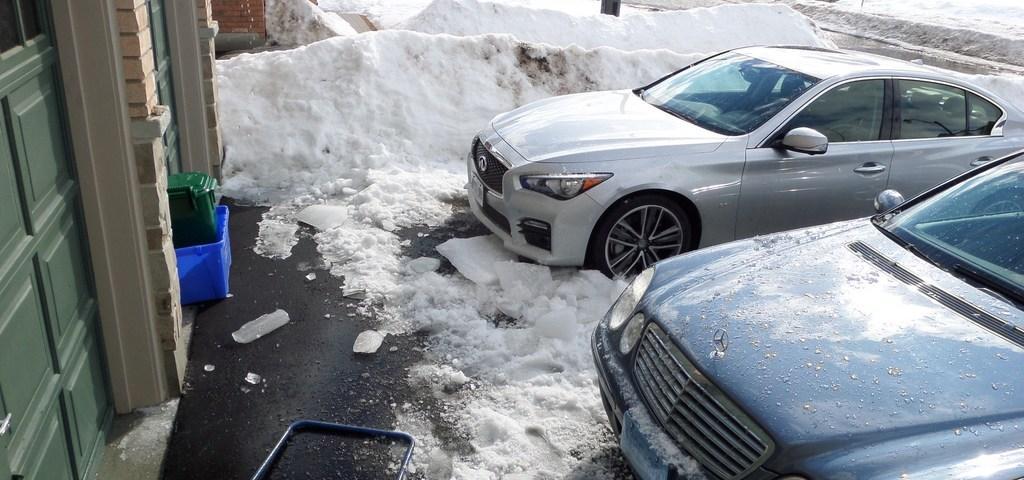In one or two sentences, can you explain what this image depicts? In this image we can see two cars. One is in white color, the other one is in blue color. Behind snow is there. Left side of the image door and wall is present. In front of the door plastic containers are there. 